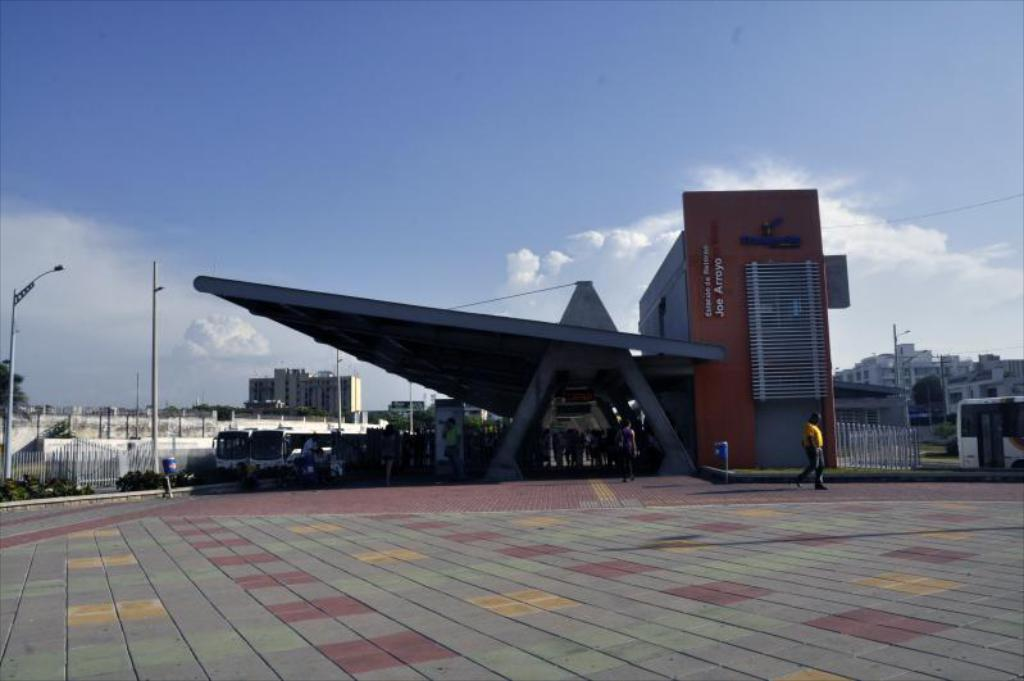Where are the people located in the image? The people are under the roof in the image. What can be seen in the distance behind the people? There are buildings, vehicles, poles, trees, boundaries, and the sky visible in the background of the image. What type of screw can be seen in the image? There is no screw present in the image. What is the profit margin of the people in the image? There is no information about profit margins in the image, as it focuses on the people's location and the background elements. 